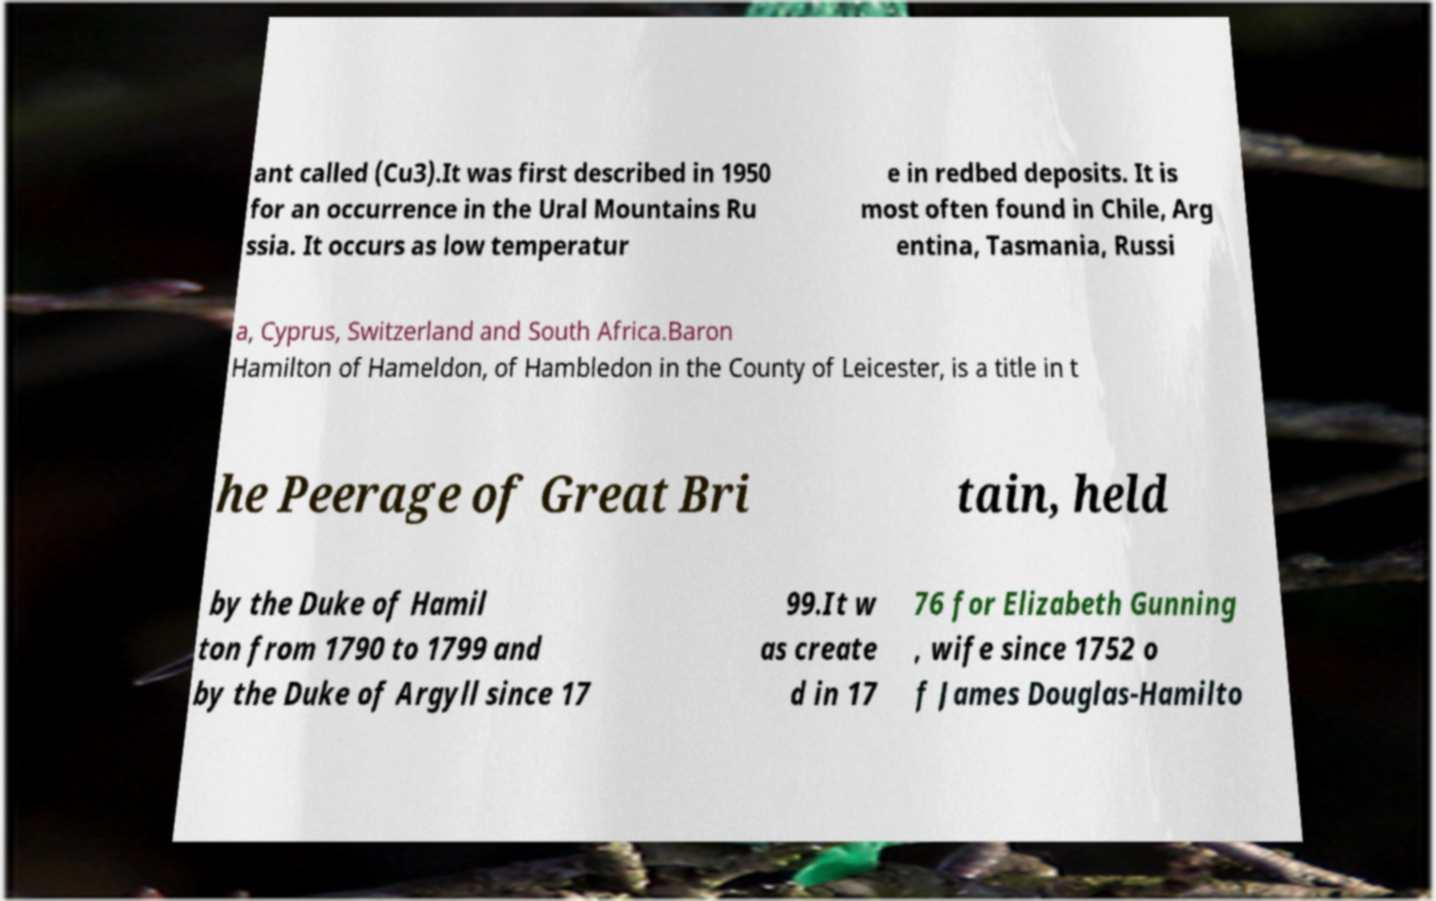For documentation purposes, I need the text within this image transcribed. Could you provide that? ant called (Cu3).It was first described in 1950 for an occurrence in the Ural Mountains Ru ssia. It occurs as low temperatur e in redbed deposits. It is most often found in Chile, Arg entina, Tasmania, Russi a, Cyprus, Switzerland and South Africa.Baron Hamilton of Hameldon, of Hambledon in the County of Leicester, is a title in t he Peerage of Great Bri tain, held by the Duke of Hamil ton from 1790 to 1799 and by the Duke of Argyll since 17 99.It w as create d in 17 76 for Elizabeth Gunning , wife since 1752 o f James Douglas-Hamilto 